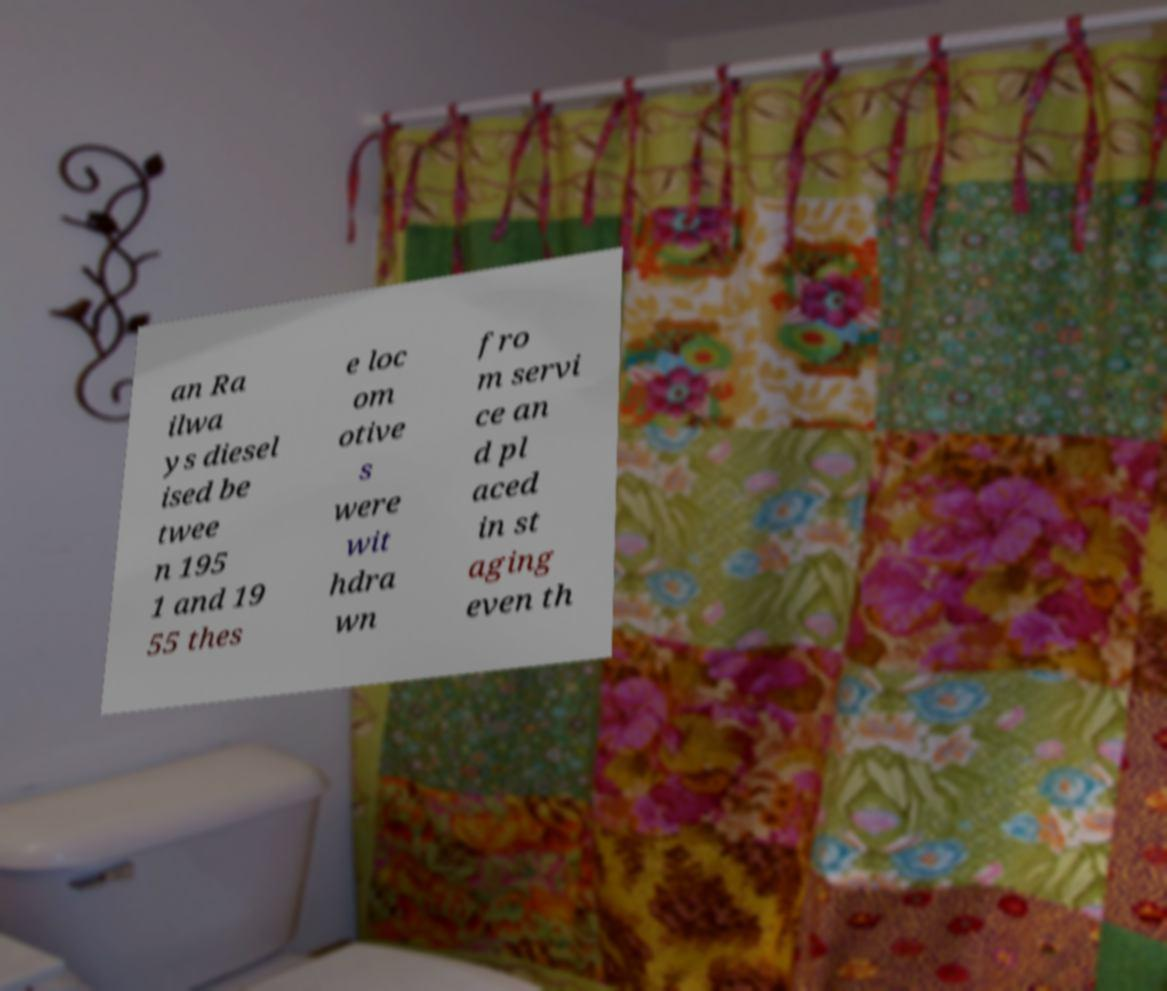For documentation purposes, I need the text within this image transcribed. Could you provide that? an Ra ilwa ys diesel ised be twee n 195 1 and 19 55 thes e loc om otive s were wit hdra wn fro m servi ce an d pl aced in st aging even th 